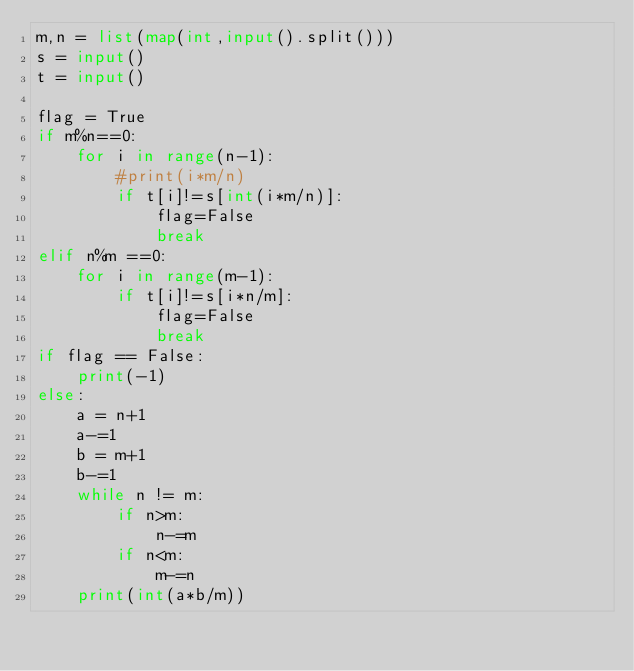Convert code to text. <code><loc_0><loc_0><loc_500><loc_500><_Python_>m,n = list(map(int,input().split()))
s = input()
t = input()

flag = True
if m%n==0:
    for i in range(n-1):
        #print(i*m/n)
        if t[i]!=s[int(i*m/n)]:
            flag=False
            break
elif n%m ==0:
    for i in range(m-1):
        if t[i]!=s[i*n/m]:
            flag=False
            break
if flag == False:
    print(-1)
else:
    a = n+1
    a-=1
    b = m+1
    b-=1
    while n != m:
        if n>m:
            n-=m
        if n<m:
            m-=n
    print(int(a*b/m))
    
    
    
        
            </code> 